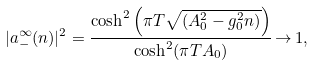Convert formula to latex. <formula><loc_0><loc_0><loc_500><loc_500>| a _ { - } ^ { \infty } ( n ) | ^ { 2 } = \frac { \cosh ^ { 2 } \left ( \pi T \sqrt { \left ( A _ { 0 } ^ { 2 } - g _ { 0 } ^ { 2 } n \right ) } \right ) } { \cosh ^ { 2 } ( \pi T A _ { 0 } ) } \, { \rightarrow } \, 1 ,</formula> 